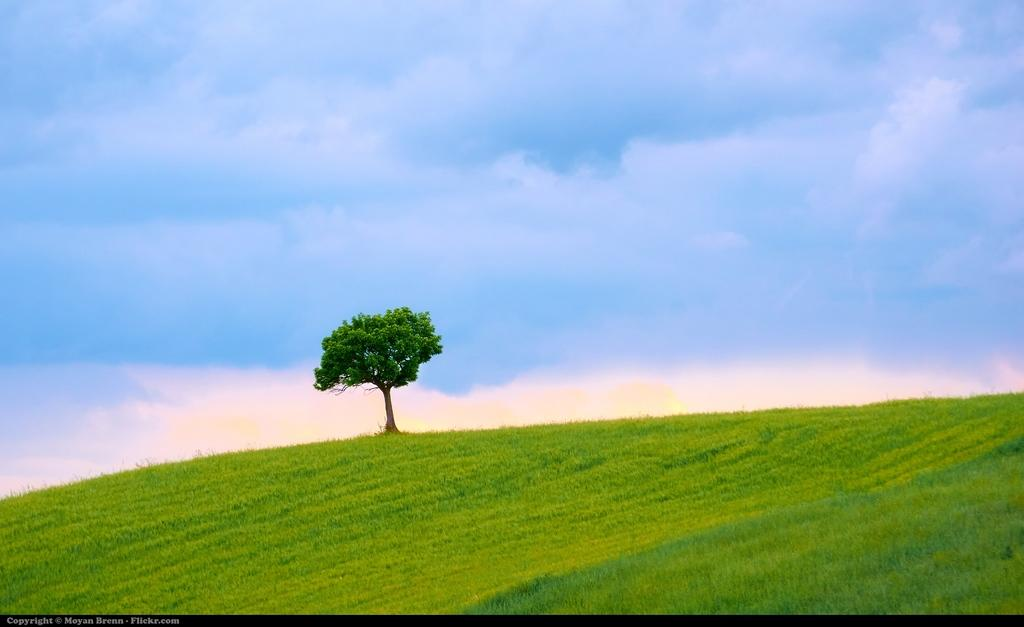What type of vegetation is present on the ground in the image? There is grass on the ground in the image. What can be seen in the background of the image? There is a tree and the sky visible in the background of the image. Is there any text present in the image? Yes, there is some text in the bottom left corner of the image. How much rice is being cooked in the image? There is no rice present in the image, so it is not possible to determine the amount being cooked. 